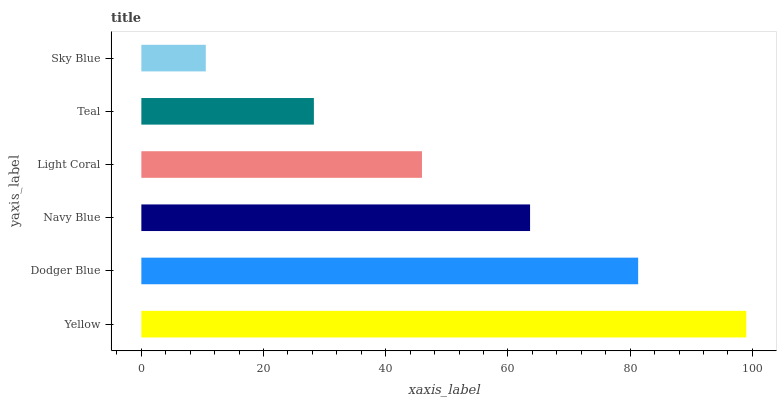Is Sky Blue the minimum?
Answer yes or no. Yes. Is Yellow the maximum?
Answer yes or no. Yes. Is Dodger Blue the minimum?
Answer yes or no. No. Is Dodger Blue the maximum?
Answer yes or no. No. Is Yellow greater than Dodger Blue?
Answer yes or no. Yes. Is Dodger Blue less than Yellow?
Answer yes or no. Yes. Is Dodger Blue greater than Yellow?
Answer yes or no. No. Is Yellow less than Dodger Blue?
Answer yes or no. No. Is Navy Blue the high median?
Answer yes or no. Yes. Is Light Coral the low median?
Answer yes or no. Yes. Is Light Coral the high median?
Answer yes or no. No. Is Dodger Blue the low median?
Answer yes or no. No. 